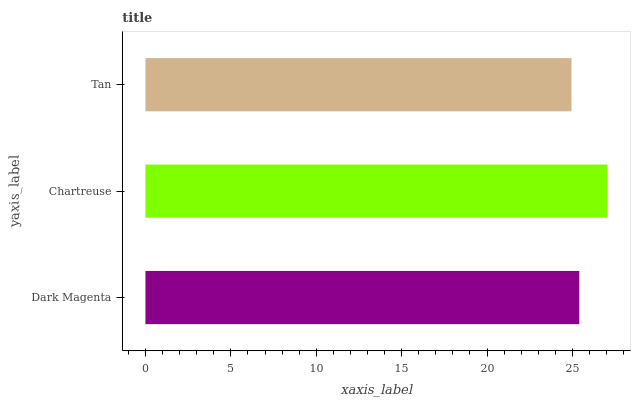Is Tan the minimum?
Answer yes or no. Yes. Is Chartreuse the maximum?
Answer yes or no. Yes. Is Chartreuse the minimum?
Answer yes or no. No. Is Tan the maximum?
Answer yes or no. No. Is Chartreuse greater than Tan?
Answer yes or no. Yes. Is Tan less than Chartreuse?
Answer yes or no. Yes. Is Tan greater than Chartreuse?
Answer yes or no. No. Is Chartreuse less than Tan?
Answer yes or no. No. Is Dark Magenta the high median?
Answer yes or no. Yes. Is Dark Magenta the low median?
Answer yes or no. Yes. Is Chartreuse the high median?
Answer yes or no. No. Is Tan the low median?
Answer yes or no. No. 